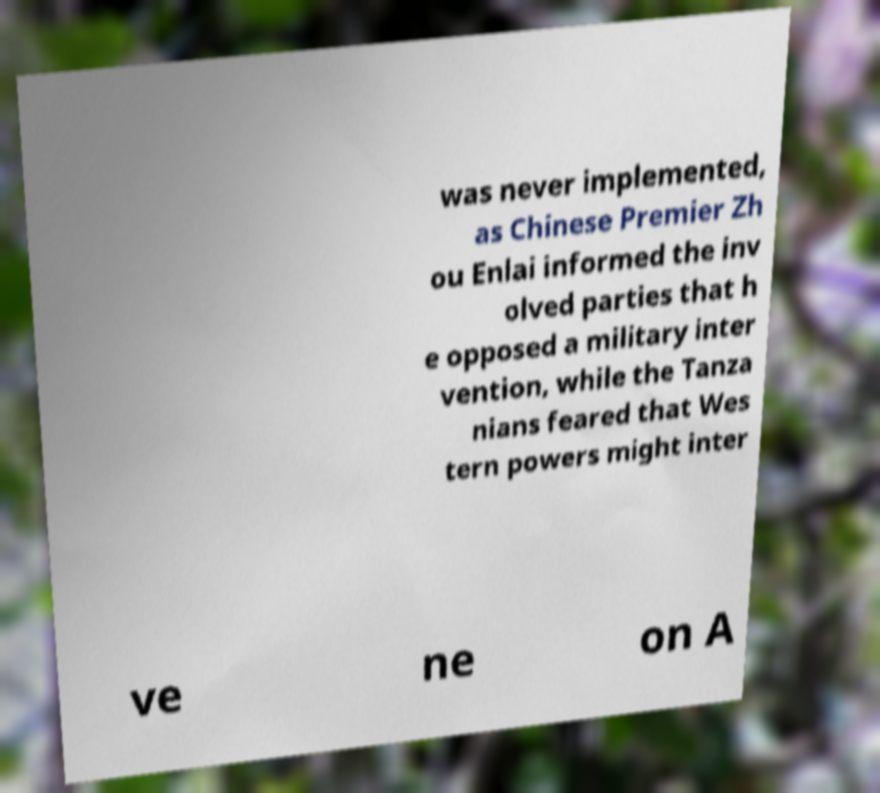Could you assist in decoding the text presented in this image and type it out clearly? was never implemented, as Chinese Premier Zh ou Enlai informed the inv olved parties that h e opposed a military inter vention, while the Tanza nians feared that Wes tern powers might inter ve ne on A 